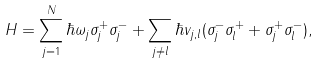<formula> <loc_0><loc_0><loc_500><loc_500>H = \sum _ { j = 1 } ^ { N } \hbar { \omega } _ { j } \sigma _ { j } ^ { + } \sigma _ { j } ^ { - } + \sum _ { j \neq l } \hbar { v } _ { j , l } ( \sigma _ { j } ^ { - } \sigma _ { l } ^ { + } + \sigma _ { j } ^ { + } \sigma _ { l } ^ { - } ) ,</formula> 